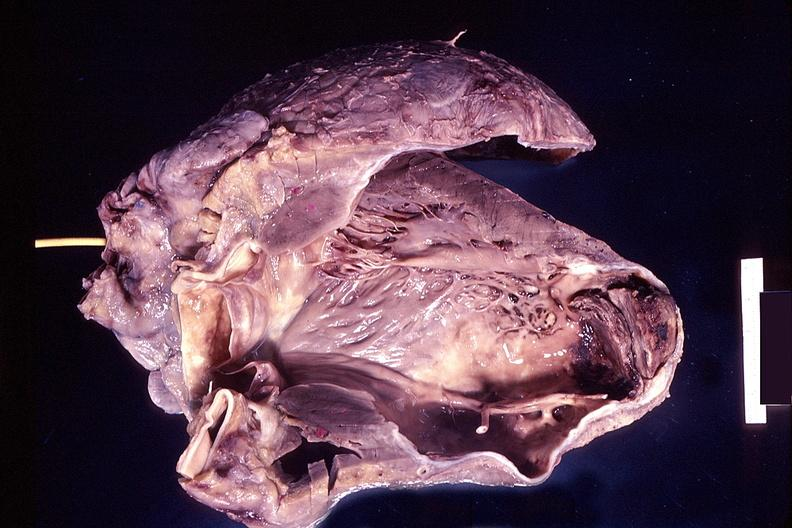s cardiovascular present?
Answer the question using a single word or phrase. Yes 